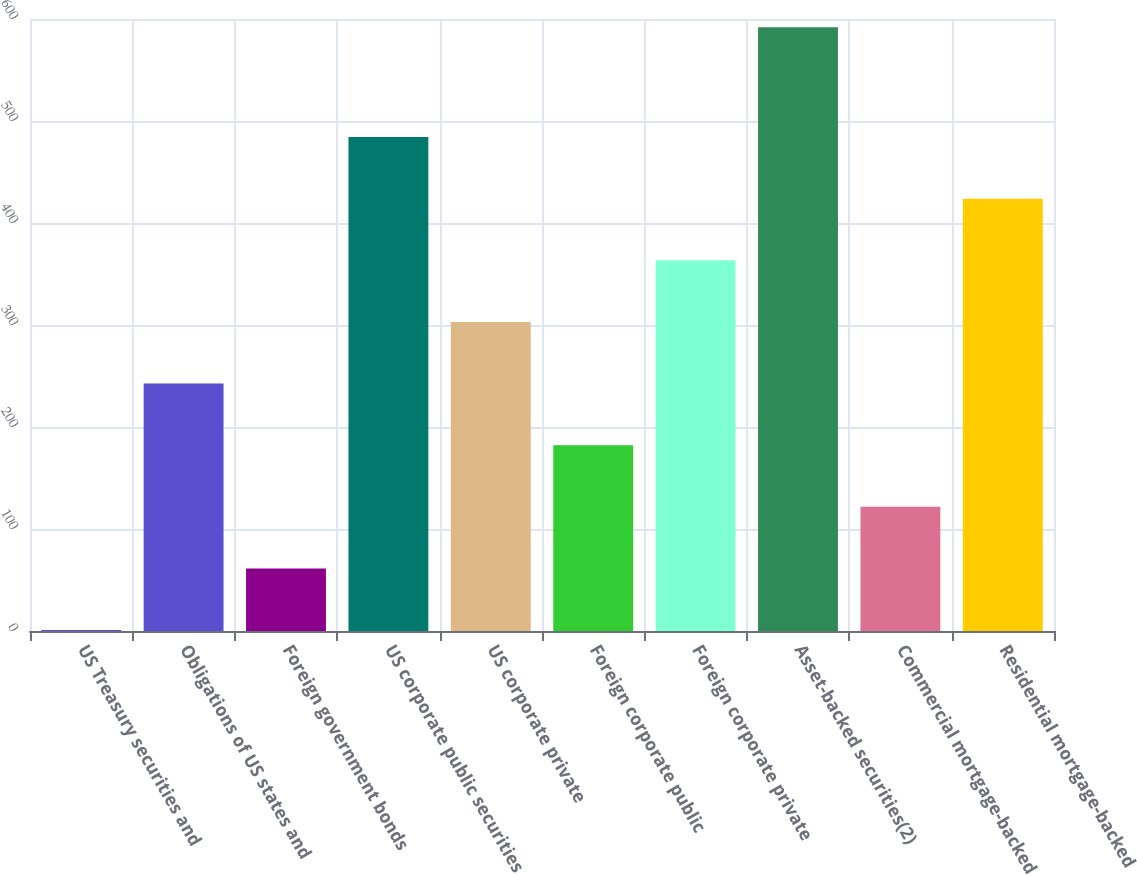<chart> <loc_0><loc_0><loc_500><loc_500><bar_chart><fcel>US Treasury securities and<fcel>Obligations of US states and<fcel>Foreign government bonds<fcel>US corporate public securities<fcel>US corporate private<fcel>Foreign corporate public<fcel>Foreign corporate private<fcel>Asset-backed securities(2)<fcel>Commercial mortgage-backed<fcel>Residential mortgage-backed<nl><fcel>0.92<fcel>242.56<fcel>61.33<fcel>484.2<fcel>302.97<fcel>182.15<fcel>363.38<fcel>592<fcel>121.74<fcel>423.79<nl></chart> 